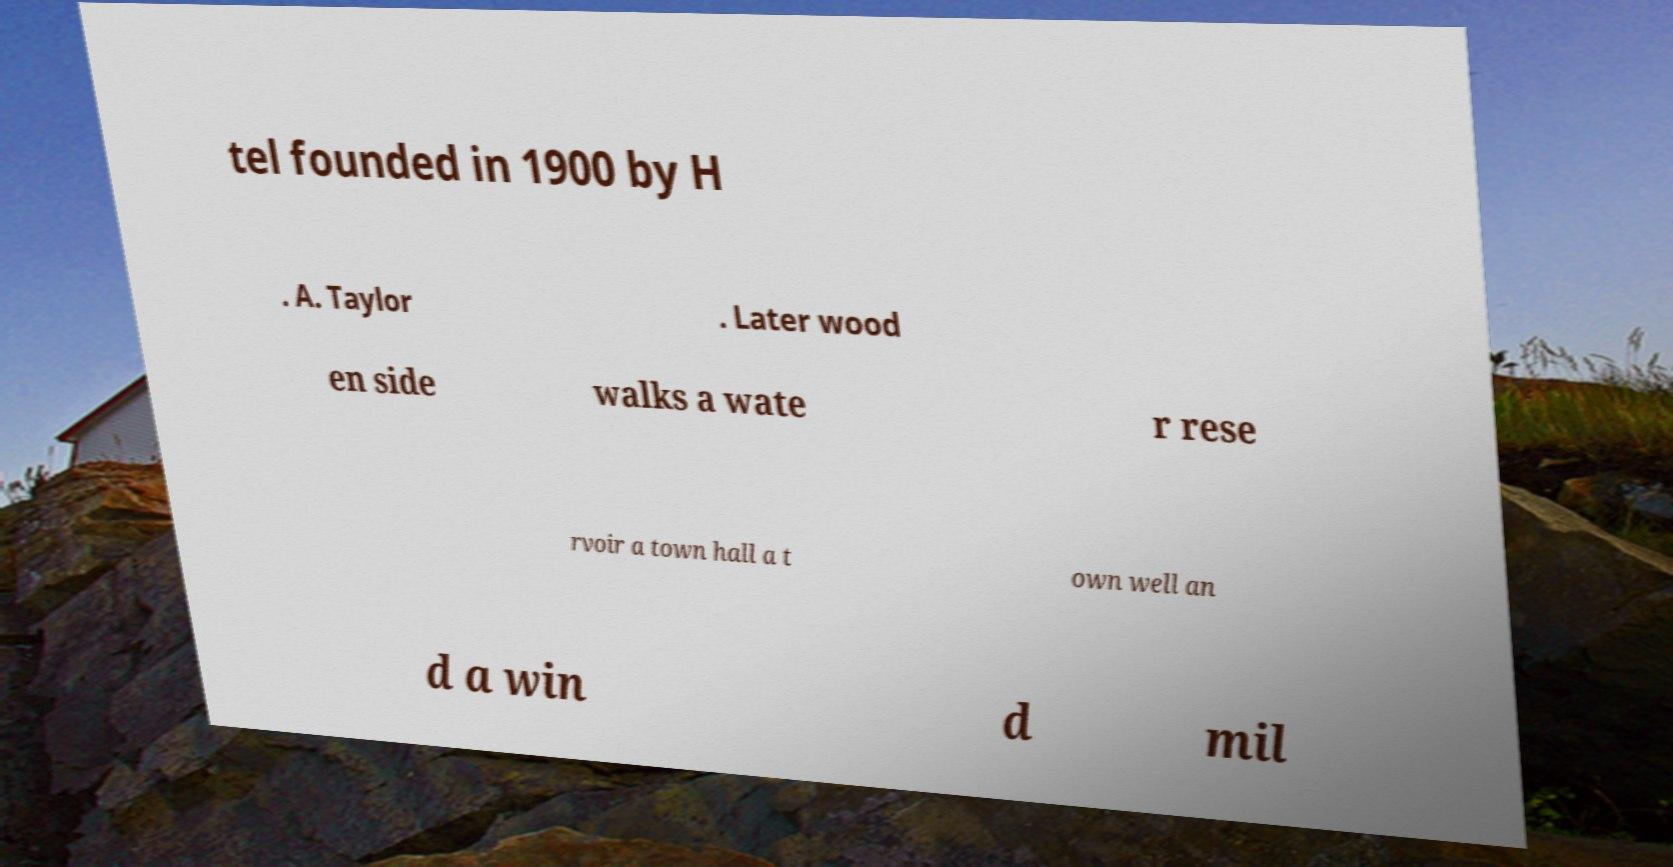I need the written content from this picture converted into text. Can you do that? tel founded in 1900 by H . A. Taylor . Later wood en side walks a wate r rese rvoir a town hall a t own well an d a win d mil 